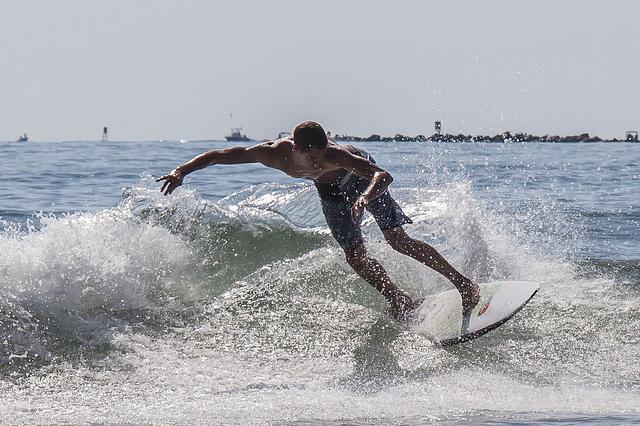Is the surfer wearing a wetsuit?
Keep it brief. No. Is the weather forecast calling for rain?
Write a very short answer. No. Is he surfing on a white surfboard?
Write a very short answer. Yes. Is the water calm or wavy?
Write a very short answer. Wavy. What is the surfer wearing?
Concise answer only. Shorts. Is the photo stylized?
Answer briefly. No. 